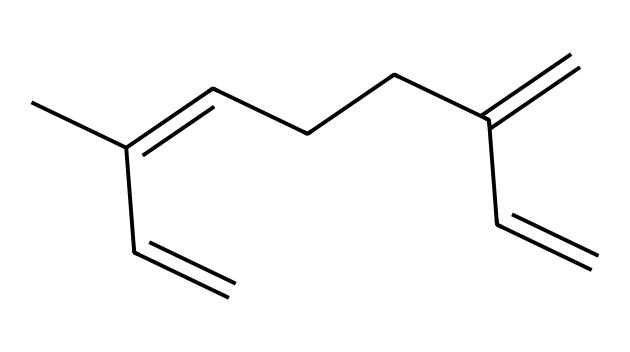How many carbon atoms are in myrcene? By examining the SMILES representation, we can count the carbon atoms. In the provided structure, the "C" symbols denote carbon atoms. There are 10 "C" in total.
Answer: ten What type of bonds are present in myrcene? The structure shows both single and double bonds. Single bonds are between most carbon atoms, with double bonds observed between some carbon pairs (shown by "=").
Answer: single and double What is the molecular formula of myrcene? To derive the molecular formula from the carbon and hydrogen count, myrcene has 10 carbon atoms and 16 hydrogen atoms, resulting in the formula C10H16.
Answer: C10H16 Which functional group is evident in myrcene’s structure? The double bonds in the structure indicate that myrcene contains a conjugated system; however, no other functional groups like alcohols or acids are indicated.
Answer: alkene How does the structural arrangement of myrcene affect its aromatic properties? The presence of multiple double bonds in a chain-like structure enhances the aromatic characteristics, while the configuration allows for potential intra-molecular interactions, helping define its use in aromatherapy.
Answer: enhances aroma What characteristic makes myrcene unique among terpenes? Myrcene is recognized for its significant presence in the cannabis plant and is known for its sedative effects among terpenes, thus enabling its role in aromatherapy during stress-relief art exhibitions.
Answer: sedative effects 